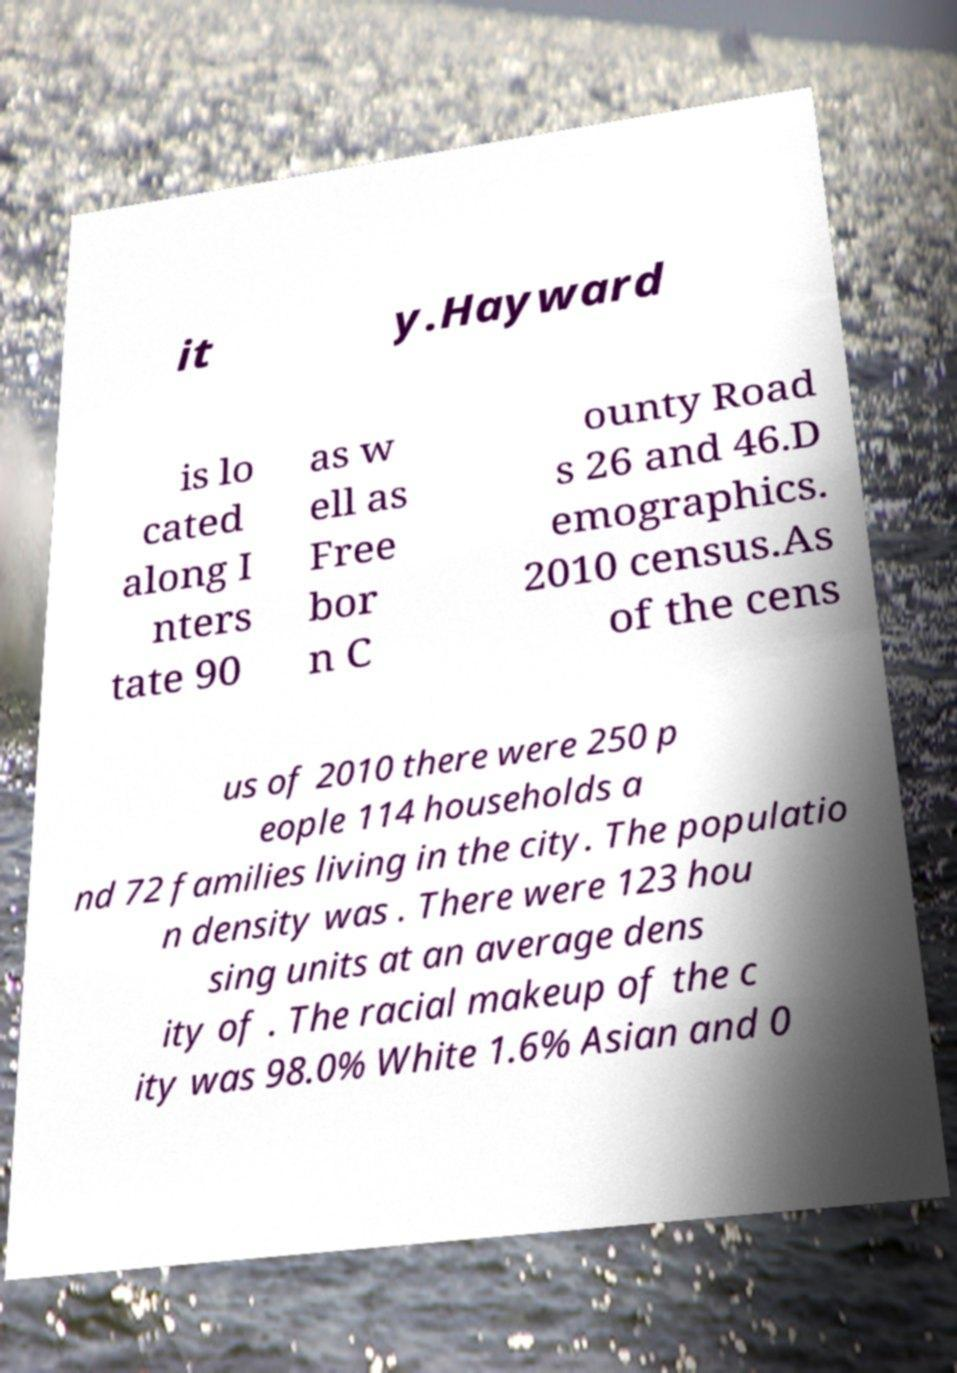Please read and relay the text visible in this image. What does it say? it y.Hayward is lo cated along I nters tate 90 as w ell as Free bor n C ounty Road s 26 and 46.D emographics. 2010 census.As of the cens us of 2010 there were 250 p eople 114 households a nd 72 families living in the city. The populatio n density was . There were 123 hou sing units at an average dens ity of . The racial makeup of the c ity was 98.0% White 1.6% Asian and 0 